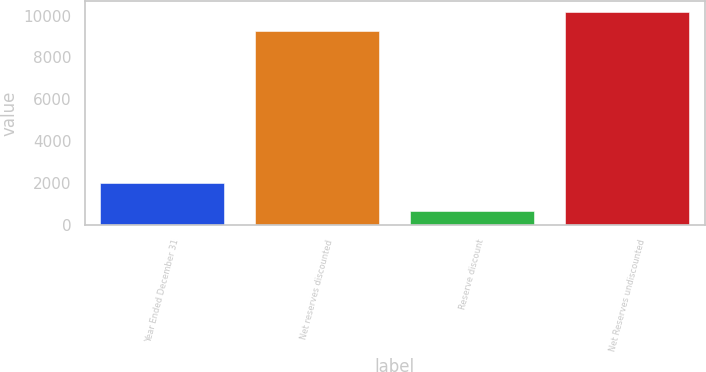Convert chart to OTSL. <chart><loc_0><loc_0><loc_500><loc_500><bar_chart><fcel>Year Ended December 31<fcel>Net reserves discounted<fcel>Reserve discount<fcel>Net Reserves undiscounted<nl><fcel>2015<fcel>9245<fcel>699<fcel>10169.5<nl></chart> 